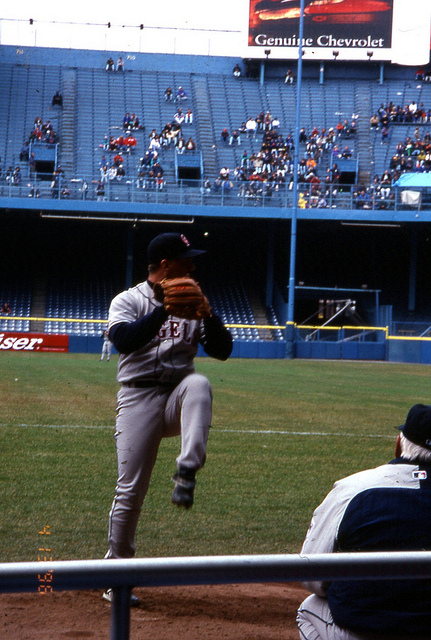Identify the text displayed in this image. Genuine Chevrolet GEL iser 